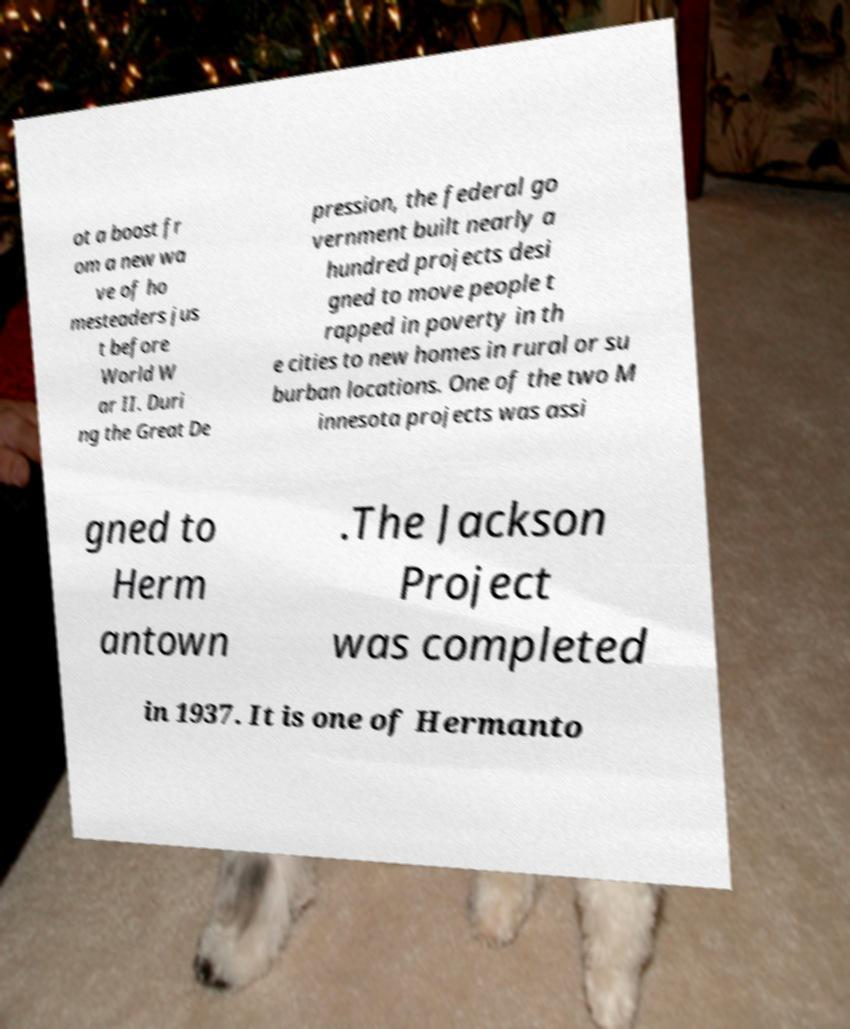Could you assist in decoding the text presented in this image and type it out clearly? ot a boost fr om a new wa ve of ho mesteaders jus t before World W ar II. Duri ng the Great De pression, the federal go vernment built nearly a hundred projects desi gned to move people t rapped in poverty in th e cities to new homes in rural or su burban locations. One of the two M innesota projects was assi gned to Herm antown .The Jackson Project was completed in 1937. It is one of Hermanto 